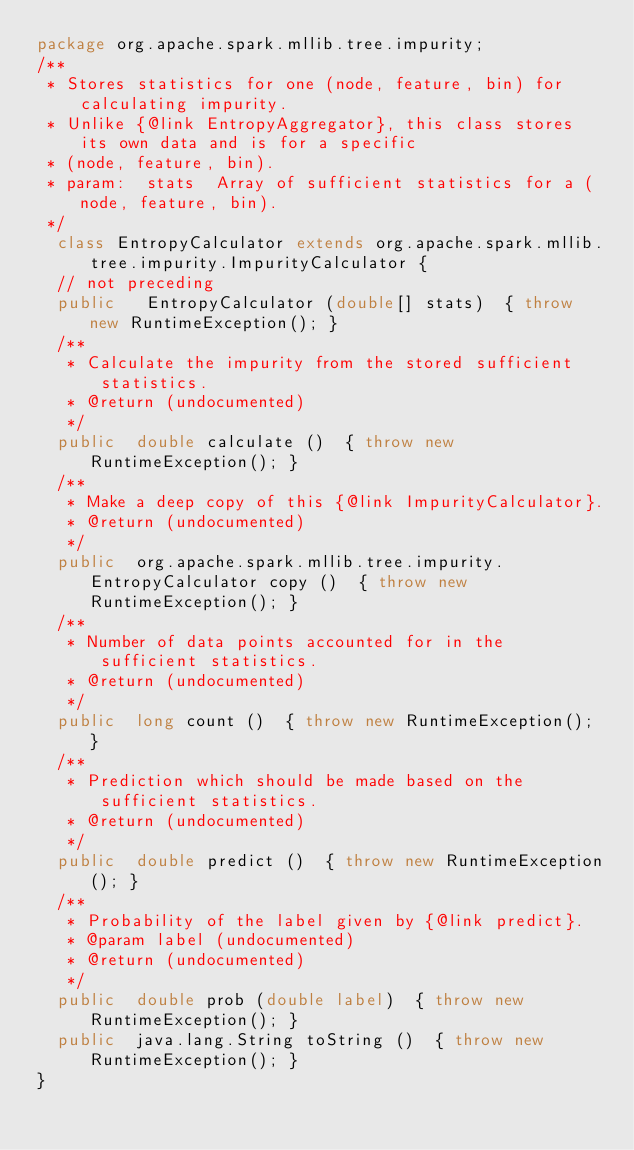Convert code to text. <code><loc_0><loc_0><loc_500><loc_500><_Java_>package org.apache.spark.mllib.tree.impurity;
/**
 * Stores statistics for one (node, feature, bin) for calculating impurity.
 * Unlike {@link EntropyAggregator}, this class stores its own data and is for a specific
 * (node, feature, bin).
 * param:  stats  Array of sufficient statistics for a (node, feature, bin).
 */
  class EntropyCalculator extends org.apache.spark.mllib.tree.impurity.ImpurityCalculator {
  // not preceding
  public   EntropyCalculator (double[] stats)  { throw new RuntimeException(); }
  /**
   * Calculate the impurity from the stored sufficient statistics.
   * @return (undocumented)
   */
  public  double calculate ()  { throw new RuntimeException(); }
  /**
   * Make a deep copy of this {@link ImpurityCalculator}.
   * @return (undocumented)
   */
  public  org.apache.spark.mllib.tree.impurity.EntropyCalculator copy ()  { throw new RuntimeException(); }
  /**
   * Number of data points accounted for in the sufficient statistics.
   * @return (undocumented)
   */
  public  long count ()  { throw new RuntimeException(); }
  /**
   * Prediction which should be made based on the sufficient statistics.
   * @return (undocumented)
   */
  public  double predict ()  { throw new RuntimeException(); }
  /**
   * Probability of the label given by {@link predict}.
   * @param label (undocumented)
   * @return (undocumented)
   */
  public  double prob (double label)  { throw new RuntimeException(); }
  public  java.lang.String toString ()  { throw new RuntimeException(); }
}
</code> 